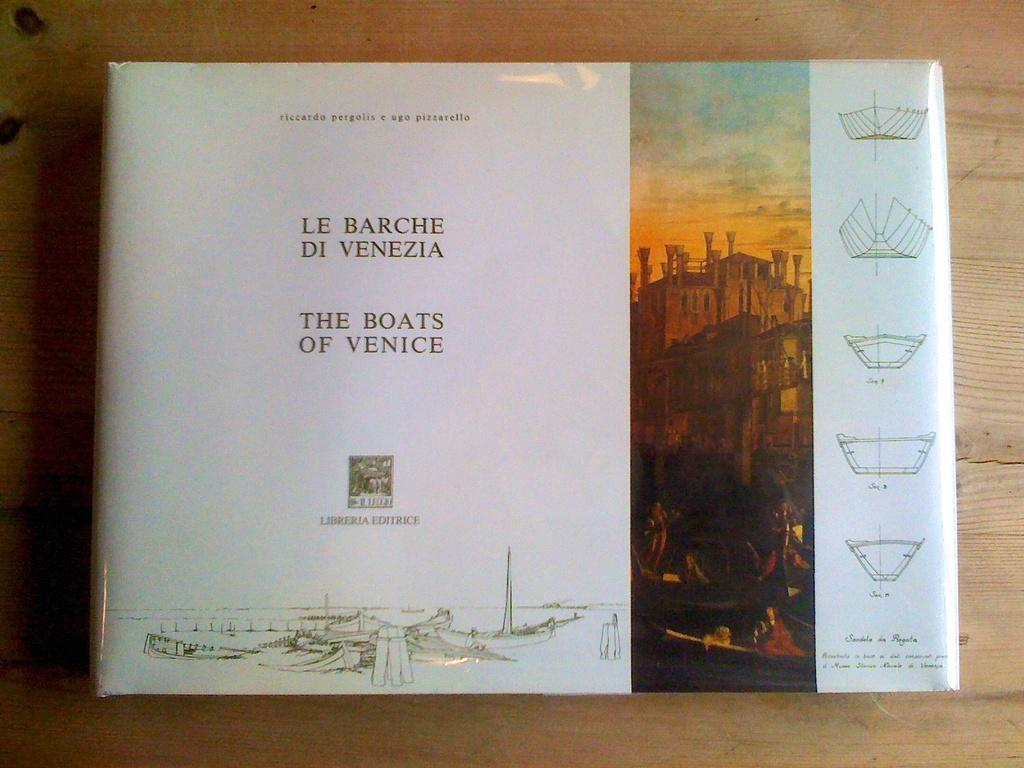<image>
Summarize the visual content of the image. A coffee table book featuring boats of Venice, with both English and Italian writing. 